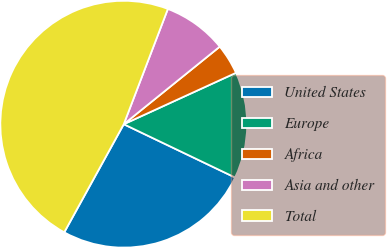Convert chart to OTSL. <chart><loc_0><loc_0><loc_500><loc_500><pie_chart><fcel>United States<fcel>Europe<fcel>Africa<fcel>Asia and other<fcel>Total<nl><fcel>25.9%<fcel>13.94%<fcel>3.98%<fcel>8.37%<fcel>47.81%<nl></chart> 